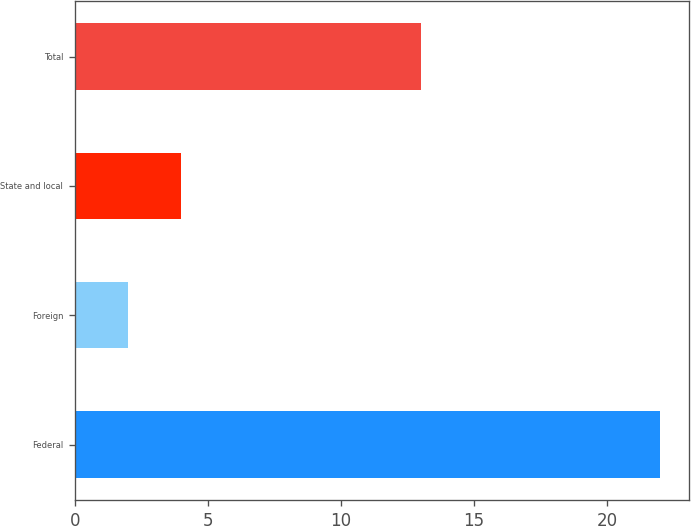Convert chart. <chart><loc_0><loc_0><loc_500><loc_500><bar_chart><fcel>Federal<fcel>Foreign<fcel>State and local<fcel>Total<nl><fcel>22<fcel>2<fcel>4<fcel>13<nl></chart> 